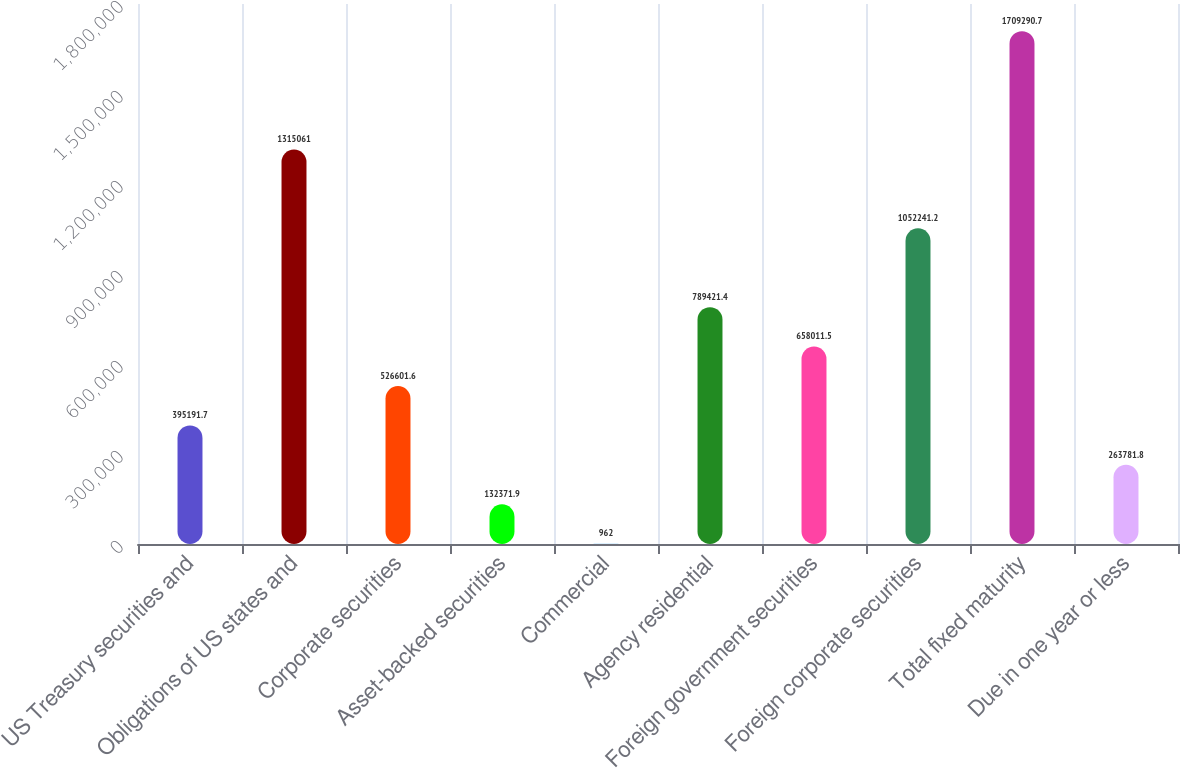Convert chart. <chart><loc_0><loc_0><loc_500><loc_500><bar_chart><fcel>US Treasury securities and<fcel>Obligations of US states and<fcel>Corporate securities<fcel>Asset-backed securities<fcel>Commercial<fcel>Agency residential<fcel>Foreign government securities<fcel>Foreign corporate securities<fcel>Total fixed maturity<fcel>Due in one year or less<nl><fcel>395192<fcel>1.31506e+06<fcel>526602<fcel>132372<fcel>962<fcel>789421<fcel>658012<fcel>1.05224e+06<fcel>1.70929e+06<fcel>263782<nl></chart> 